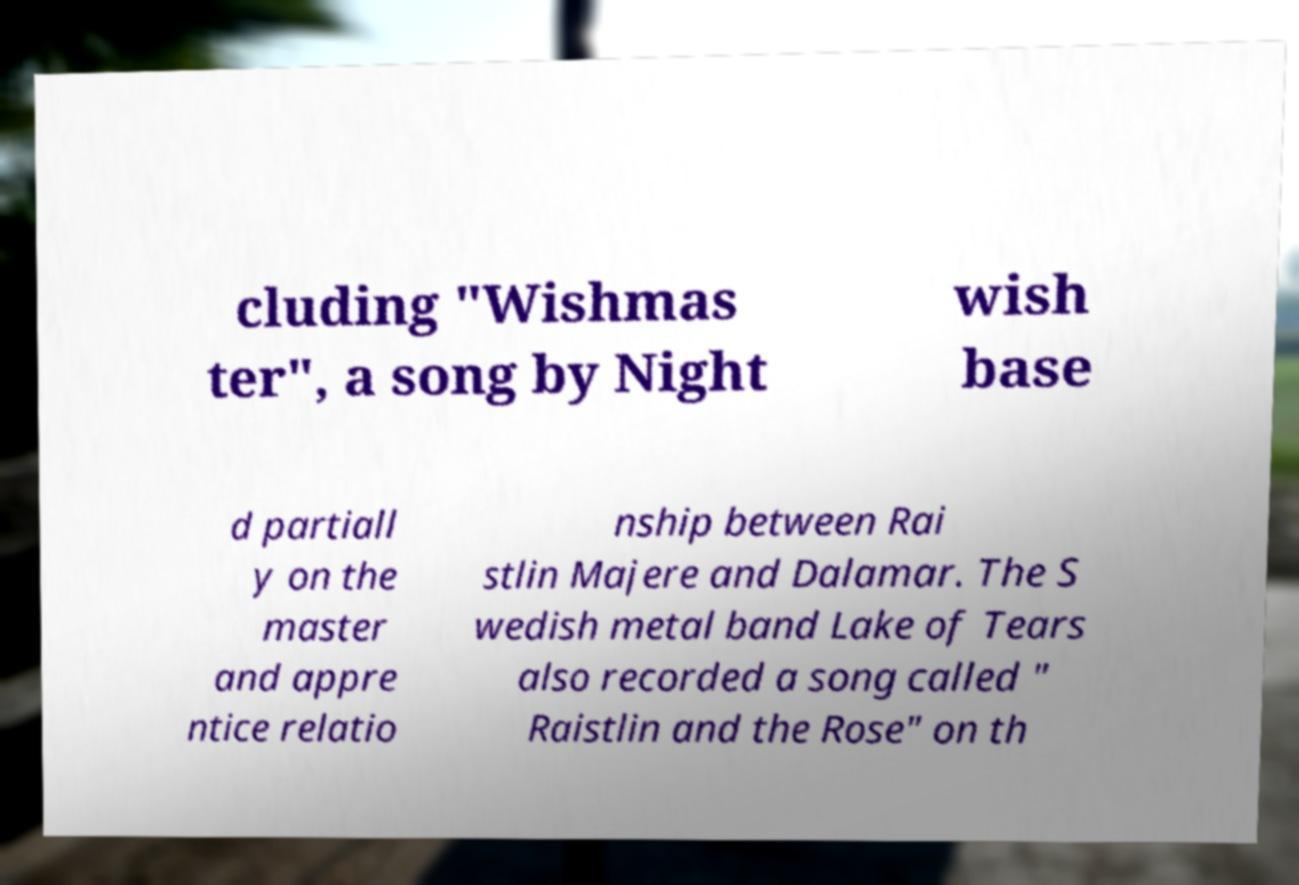I need the written content from this picture converted into text. Can you do that? cluding "Wishmas ter", a song by Night wish base d partiall y on the master and appre ntice relatio nship between Rai stlin Majere and Dalamar. The S wedish metal band Lake of Tears also recorded a song called " Raistlin and the Rose" on th 